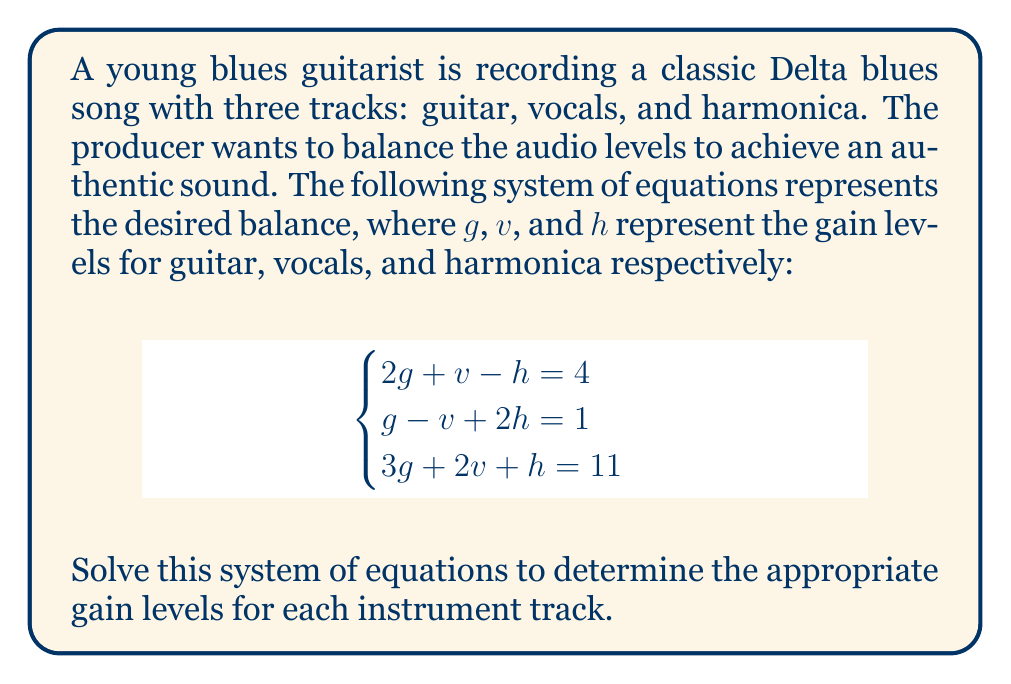Help me with this question. To solve this system of equations, we'll use the Gaussian elimination method:

1) First, write the augmented matrix:

   $$\begin{bmatrix}
   2 & 1 & -1 & 4 \\
   1 & -1 & 2 & 1 \\
   3 & 2 & 1 & 11
   \end{bmatrix}$$

2) Multiply the first row by -1/2 and add it to the second row:

   $$\begin{bmatrix}
   2 & 1 & -1 & 4 \\
   0 & -3/2 & 5/2 & -1 \\
   3 & 2 & 1 & 11
   \end{bmatrix}$$

3) Multiply the first row by -3/2 and add it to the third row:

   $$\begin{bmatrix}
   2 & 1 & -1 & 4 \\
   0 & -3/2 & 5/2 & -1 \\
   0 & 1/2 & 5/2 & 5
   \end{bmatrix}$$

4) Multiply the second row by -1/3 and add it to the third row:

   $$\begin{bmatrix}
   2 & 1 & -1 & 4 \\
   0 & -3/2 & 5/2 & -1 \\
   0 & 0 & 10/3 & 16/3
   \end{bmatrix}$$

5) Now we have an upper triangular matrix. Solve for $h$:

   $\frac{10}{3}h = \frac{16}{3}$
   $h = \frac{16}{10} = \frac{8}{5} = 1.6$

6) Substitute $h$ into the second equation:

   $-\frac{3}{2}v + \frac{5}{2}(1.6) = -1$
   $-\frac{3}{2}v + 4 = -1$
   $-\frac{3}{2}v = -5$
   $v = \frac{10}{3} \approx 3.33$

7) Substitute $h$ and $v$ into the first equation:

   $2g + \frac{10}{3} - 1.6 = 4$
   $2g = 4 - \frac{10}{3} + 1.6 = \frac{7}{3}$
   $g = \frac{7}{6} \approx 1.17$

Therefore, the gain levels are:
Guitar (g): $\frac{7}{6}$
Vocals (v): $\frac{10}{3}$
Harmonica (h): $\frac{8}{5}$
Answer: $g = \frac{7}{6}, v = \frac{10}{3}, h = \frac{8}{5}$ 